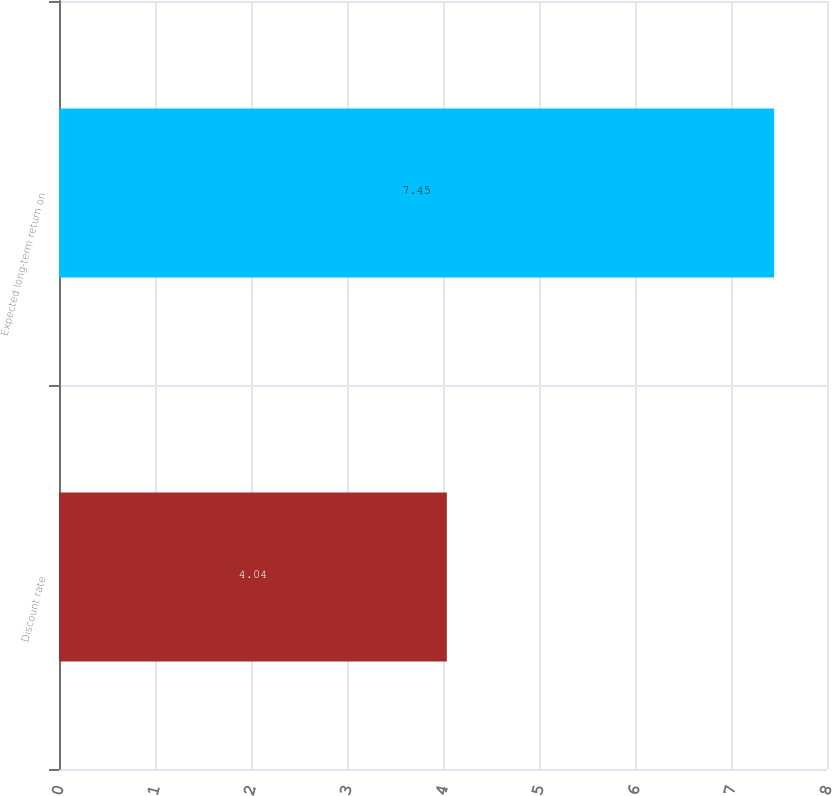<chart> <loc_0><loc_0><loc_500><loc_500><bar_chart><fcel>Discount rate<fcel>Expected long-term return on<nl><fcel>4.04<fcel>7.45<nl></chart> 